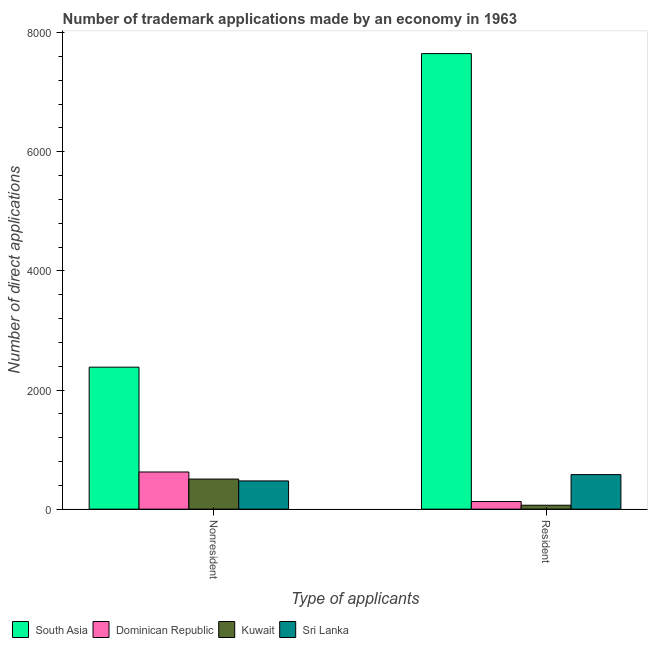How many different coloured bars are there?
Offer a very short reply. 4. Are the number of bars on each tick of the X-axis equal?
Your answer should be very brief. Yes. What is the label of the 1st group of bars from the left?
Offer a terse response. Nonresident. What is the number of trademark applications made by non residents in Kuwait?
Give a very brief answer. 505. Across all countries, what is the maximum number of trademark applications made by non residents?
Your answer should be compact. 2384. Across all countries, what is the minimum number of trademark applications made by residents?
Provide a short and direct response. 66. In which country was the number of trademark applications made by residents maximum?
Your answer should be very brief. South Asia. In which country was the number of trademark applications made by residents minimum?
Your response must be concise. Kuwait. What is the total number of trademark applications made by residents in the graph?
Give a very brief answer. 8423. What is the difference between the number of trademark applications made by non residents in Sri Lanka and that in Dominican Republic?
Give a very brief answer. -150. What is the difference between the number of trademark applications made by residents in Sri Lanka and the number of trademark applications made by non residents in Dominican Republic?
Offer a terse response. -44. What is the average number of trademark applications made by non residents per country?
Provide a succinct answer. 996.75. What is the difference between the number of trademark applications made by non residents and number of trademark applications made by residents in Dominican Republic?
Give a very brief answer. 496. What is the ratio of the number of trademark applications made by residents in Kuwait to that in Dominican Republic?
Ensure brevity in your answer.  0.52. Is the number of trademark applications made by non residents in Kuwait less than that in South Asia?
Offer a very short reply. Yes. What does the 4th bar from the left in Resident represents?
Offer a terse response. Sri Lanka. What does the 1st bar from the right in Resident represents?
Keep it short and to the point. Sri Lanka. Where does the legend appear in the graph?
Offer a very short reply. Bottom left. How many legend labels are there?
Offer a terse response. 4. What is the title of the graph?
Your response must be concise. Number of trademark applications made by an economy in 1963. What is the label or title of the X-axis?
Provide a short and direct response. Type of applicants. What is the label or title of the Y-axis?
Make the answer very short. Number of direct applications. What is the Number of direct applications in South Asia in Nonresident?
Make the answer very short. 2384. What is the Number of direct applications of Dominican Republic in Nonresident?
Your answer should be very brief. 624. What is the Number of direct applications of Kuwait in Nonresident?
Ensure brevity in your answer.  505. What is the Number of direct applications in Sri Lanka in Nonresident?
Your answer should be very brief. 474. What is the Number of direct applications in South Asia in Resident?
Make the answer very short. 7649. What is the Number of direct applications of Dominican Republic in Resident?
Your answer should be compact. 128. What is the Number of direct applications of Kuwait in Resident?
Give a very brief answer. 66. What is the Number of direct applications of Sri Lanka in Resident?
Offer a terse response. 580. Across all Type of applicants, what is the maximum Number of direct applications in South Asia?
Offer a very short reply. 7649. Across all Type of applicants, what is the maximum Number of direct applications of Dominican Republic?
Provide a succinct answer. 624. Across all Type of applicants, what is the maximum Number of direct applications in Kuwait?
Ensure brevity in your answer.  505. Across all Type of applicants, what is the maximum Number of direct applications of Sri Lanka?
Your answer should be compact. 580. Across all Type of applicants, what is the minimum Number of direct applications of South Asia?
Offer a very short reply. 2384. Across all Type of applicants, what is the minimum Number of direct applications in Dominican Republic?
Give a very brief answer. 128. Across all Type of applicants, what is the minimum Number of direct applications in Sri Lanka?
Your response must be concise. 474. What is the total Number of direct applications of South Asia in the graph?
Give a very brief answer. 1.00e+04. What is the total Number of direct applications of Dominican Republic in the graph?
Provide a succinct answer. 752. What is the total Number of direct applications of Kuwait in the graph?
Offer a very short reply. 571. What is the total Number of direct applications in Sri Lanka in the graph?
Give a very brief answer. 1054. What is the difference between the Number of direct applications in South Asia in Nonresident and that in Resident?
Your answer should be very brief. -5265. What is the difference between the Number of direct applications in Dominican Republic in Nonresident and that in Resident?
Give a very brief answer. 496. What is the difference between the Number of direct applications in Kuwait in Nonresident and that in Resident?
Provide a short and direct response. 439. What is the difference between the Number of direct applications in Sri Lanka in Nonresident and that in Resident?
Your answer should be very brief. -106. What is the difference between the Number of direct applications in South Asia in Nonresident and the Number of direct applications in Dominican Republic in Resident?
Offer a terse response. 2256. What is the difference between the Number of direct applications of South Asia in Nonresident and the Number of direct applications of Kuwait in Resident?
Offer a very short reply. 2318. What is the difference between the Number of direct applications of South Asia in Nonresident and the Number of direct applications of Sri Lanka in Resident?
Give a very brief answer. 1804. What is the difference between the Number of direct applications of Dominican Republic in Nonresident and the Number of direct applications of Kuwait in Resident?
Provide a short and direct response. 558. What is the difference between the Number of direct applications in Kuwait in Nonresident and the Number of direct applications in Sri Lanka in Resident?
Make the answer very short. -75. What is the average Number of direct applications in South Asia per Type of applicants?
Offer a terse response. 5016.5. What is the average Number of direct applications of Dominican Republic per Type of applicants?
Offer a terse response. 376. What is the average Number of direct applications of Kuwait per Type of applicants?
Ensure brevity in your answer.  285.5. What is the average Number of direct applications of Sri Lanka per Type of applicants?
Your answer should be compact. 527. What is the difference between the Number of direct applications in South Asia and Number of direct applications in Dominican Republic in Nonresident?
Keep it short and to the point. 1760. What is the difference between the Number of direct applications of South Asia and Number of direct applications of Kuwait in Nonresident?
Provide a succinct answer. 1879. What is the difference between the Number of direct applications of South Asia and Number of direct applications of Sri Lanka in Nonresident?
Offer a very short reply. 1910. What is the difference between the Number of direct applications of Dominican Republic and Number of direct applications of Kuwait in Nonresident?
Ensure brevity in your answer.  119. What is the difference between the Number of direct applications in Dominican Republic and Number of direct applications in Sri Lanka in Nonresident?
Offer a very short reply. 150. What is the difference between the Number of direct applications in Kuwait and Number of direct applications in Sri Lanka in Nonresident?
Offer a very short reply. 31. What is the difference between the Number of direct applications in South Asia and Number of direct applications in Dominican Republic in Resident?
Offer a very short reply. 7521. What is the difference between the Number of direct applications in South Asia and Number of direct applications in Kuwait in Resident?
Your answer should be very brief. 7583. What is the difference between the Number of direct applications of South Asia and Number of direct applications of Sri Lanka in Resident?
Your answer should be compact. 7069. What is the difference between the Number of direct applications in Dominican Republic and Number of direct applications in Kuwait in Resident?
Make the answer very short. 62. What is the difference between the Number of direct applications of Dominican Republic and Number of direct applications of Sri Lanka in Resident?
Provide a succinct answer. -452. What is the difference between the Number of direct applications of Kuwait and Number of direct applications of Sri Lanka in Resident?
Your response must be concise. -514. What is the ratio of the Number of direct applications in South Asia in Nonresident to that in Resident?
Your answer should be compact. 0.31. What is the ratio of the Number of direct applications of Dominican Republic in Nonresident to that in Resident?
Your answer should be very brief. 4.88. What is the ratio of the Number of direct applications of Kuwait in Nonresident to that in Resident?
Offer a very short reply. 7.65. What is the ratio of the Number of direct applications of Sri Lanka in Nonresident to that in Resident?
Your answer should be compact. 0.82. What is the difference between the highest and the second highest Number of direct applications of South Asia?
Offer a terse response. 5265. What is the difference between the highest and the second highest Number of direct applications in Dominican Republic?
Keep it short and to the point. 496. What is the difference between the highest and the second highest Number of direct applications of Kuwait?
Provide a short and direct response. 439. What is the difference between the highest and the second highest Number of direct applications in Sri Lanka?
Your answer should be very brief. 106. What is the difference between the highest and the lowest Number of direct applications of South Asia?
Your response must be concise. 5265. What is the difference between the highest and the lowest Number of direct applications in Dominican Republic?
Your response must be concise. 496. What is the difference between the highest and the lowest Number of direct applications in Kuwait?
Offer a terse response. 439. What is the difference between the highest and the lowest Number of direct applications in Sri Lanka?
Ensure brevity in your answer.  106. 